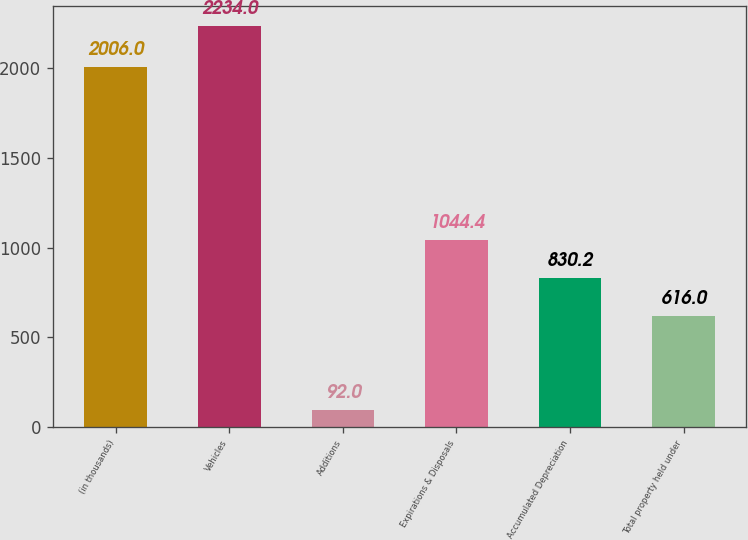Convert chart. <chart><loc_0><loc_0><loc_500><loc_500><bar_chart><fcel>(in thousands)<fcel>Vehicles<fcel>Additions<fcel>Expirations & Disposals<fcel>Accumulated Depreciation<fcel>Total property held under<nl><fcel>2006<fcel>2234<fcel>92<fcel>1044.4<fcel>830.2<fcel>616<nl></chart> 